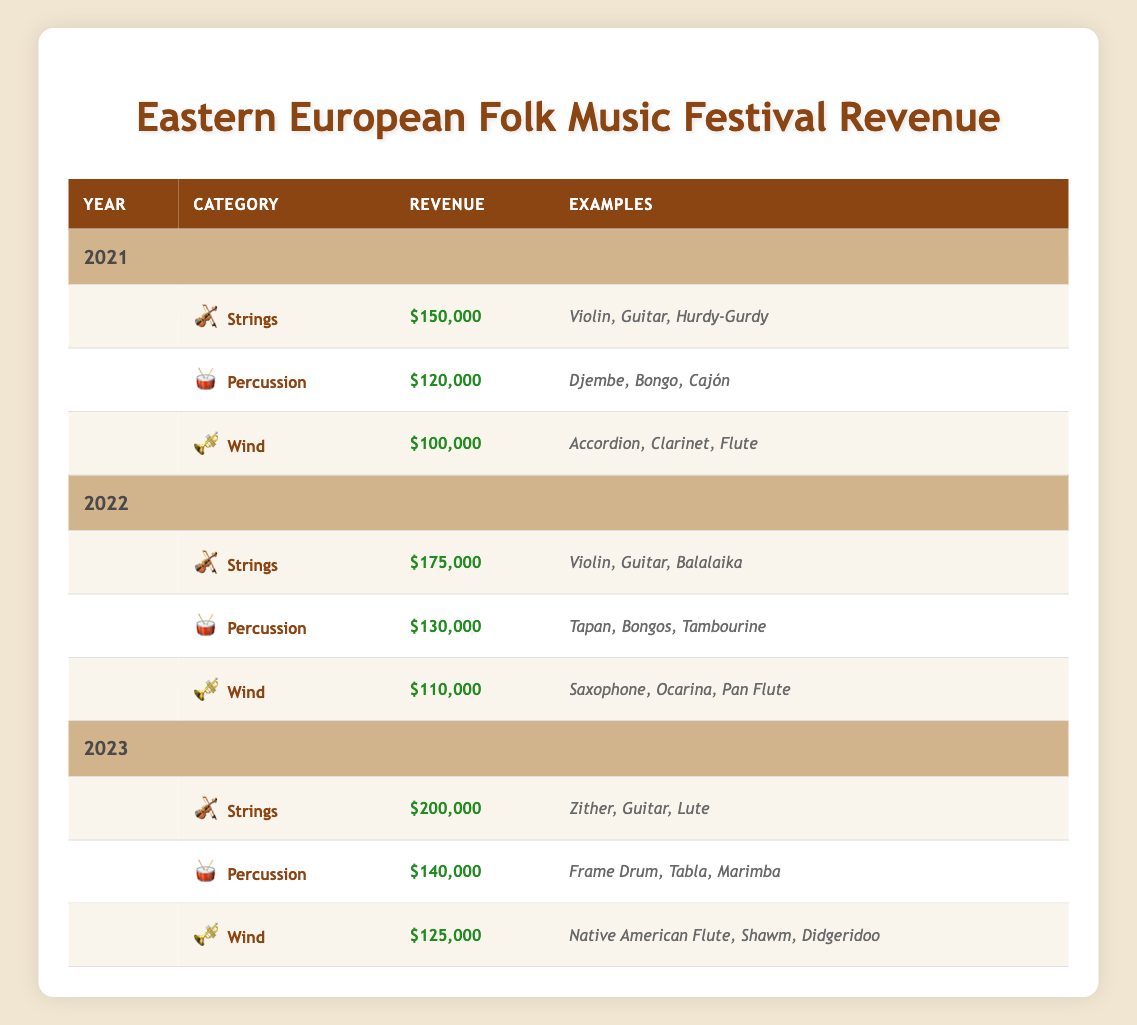What was the total revenue from wind instruments in 2022? The wind instruments category in 2022 generated a revenue of $110,000.
Answer: $110,000 Which instrument category saw the highest revenue increase from 2021 to 2023? The strings category showed an increase from $150,000 in 2021 to $200,000 in 2023, which is a difference of $50,000. This is the highest increase compared to other categories.
Answer: Strings Did percussion instruments generate more revenue in 2022 than in 2021? In 2022, percussion instruments generated $130,000, whereas in 2021 they generated $120,000. Since $130,000 > $120,000, the statement is true.
Answer: Yes What is the combined revenue of all instrument categories in 2023? The combined revenue in 2023 is calculated as follows: Strings ($200,000) + Percussion ($140,000) + Wind ($125,000) = $200,000 + $140,000 + $125,000 = $465,000.
Answer: $465,000 Which year had the lowest total revenue from traditional instruments? Adding revenue for each year: 2021: $150,000 + $120,000 + $100,000 = $370,000; 2022: $175,000 + $130,000 + $110,000 = $415,000; 2023: $200,000 + $140,000 + $125,000 = $465,000. 2021 had the lowest total revenue at $370,000.
Answer: 2021 What was the revenue difference between strings and percussion in 2022? In 2022, strings generated $175,000 and percussion generated $130,000. The difference is $175,000 - $130,000 = $45,000.
Answer: $45,000 Is it true that the accordion is an example of a wind instrument? According to the table, the accordion is listed under wind instruments, indicating that the statement is true.
Answer: Yes Which instrument category had the second highest revenue in 2023? In 2023, the revenues are: Strings - $200,000, Percussion - $140,000, Wind - $125,000. The second highest revenue is from percussion at $140,000.
Answer: Percussion 